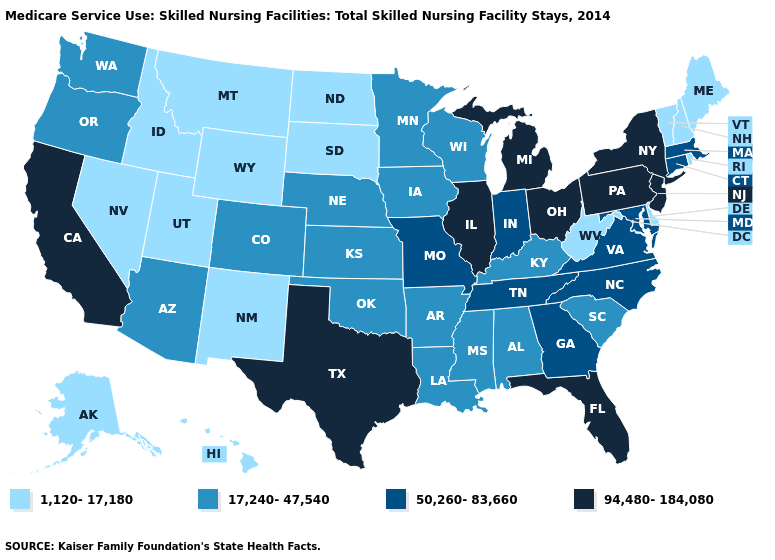What is the value of Montana?
Write a very short answer. 1,120-17,180. Name the states that have a value in the range 50,260-83,660?
Answer briefly. Connecticut, Georgia, Indiana, Maryland, Massachusetts, Missouri, North Carolina, Tennessee, Virginia. What is the lowest value in states that border Kansas?
Concise answer only. 17,240-47,540. What is the value of Texas?
Be succinct. 94,480-184,080. Which states have the highest value in the USA?
Concise answer only. California, Florida, Illinois, Michigan, New Jersey, New York, Ohio, Pennsylvania, Texas. Name the states that have a value in the range 1,120-17,180?
Be succinct. Alaska, Delaware, Hawaii, Idaho, Maine, Montana, Nevada, New Hampshire, New Mexico, North Dakota, Rhode Island, South Dakota, Utah, Vermont, West Virginia, Wyoming. Name the states that have a value in the range 50,260-83,660?
Answer briefly. Connecticut, Georgia, Indiana, Maryland, Massachusetts, Missouri, North Carolina, Tennessee, Virginia. Does Arizona have a higher value than South Dakota?
Concise answer only. Yes. What is the value of New Mexico?
Write a very short answer. 1,120-17,180. Name the states that have a value in the range 94,480-184,080?
Quick response, please. California, Florida, Illinois, Michigan, New Jersey, New York, Ohio, Pennsylvania, Texas. Is the legend a continuous bar?
Concise answer only. No. What is the value of Kansas?
Short answer required. 17,240-47,540. Which states have the lowest value in the Northeast?
Quick response, please. Maine, New Hampshire, Rhode Island, Vermont. Name the states that have a value in the range 1,120-17,180?
Answer briefly. Alaska, Delaware, Hawaii, Idaho, Maine, Montana, Nevada, New Hampshire, New Mexico, North Dakota, Rhode Island, South Dakota, Utah, Vermont, West Virginia, Wyoming. Does the first symbol in the legend represent the smallest category?
Give a very brief answer. Yes. 